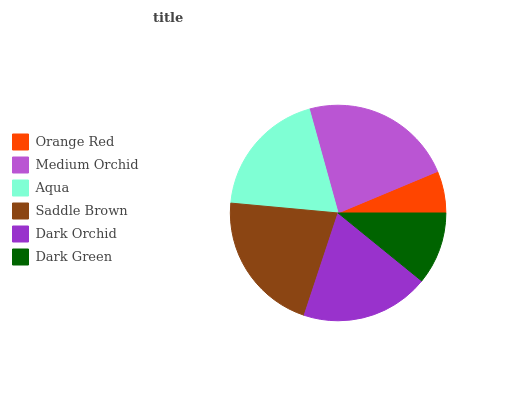Is Orange Red the minimum?
Answer yes or no. Yes. Is Medium Orchid the maximum?
Answer yes or no. Yes. Is Aqua the minimum?
Answer yes or no. No. Is Aqua the maximum?
Answer yes or no. No. Is Medium Orchid greater than Aqua?
Answer yes or no. Yes. Is Aqua less than Medium Orchid?
Answer yes or no. Yes. Is Aqua greater than Medium Orchid?
Answer yes or no. No. Is Medium Orchid less than Aqua?
Answer yes or no. No. Is Aqua the high median?
Answer yes or no. Yes. Is Dark Orchid the low median?
Answer yes or no. Yes. Is Saddle Brown the high median?
Answer yes or no. No. Is Saddle Brown the low median?
Answer yes or no. No. 